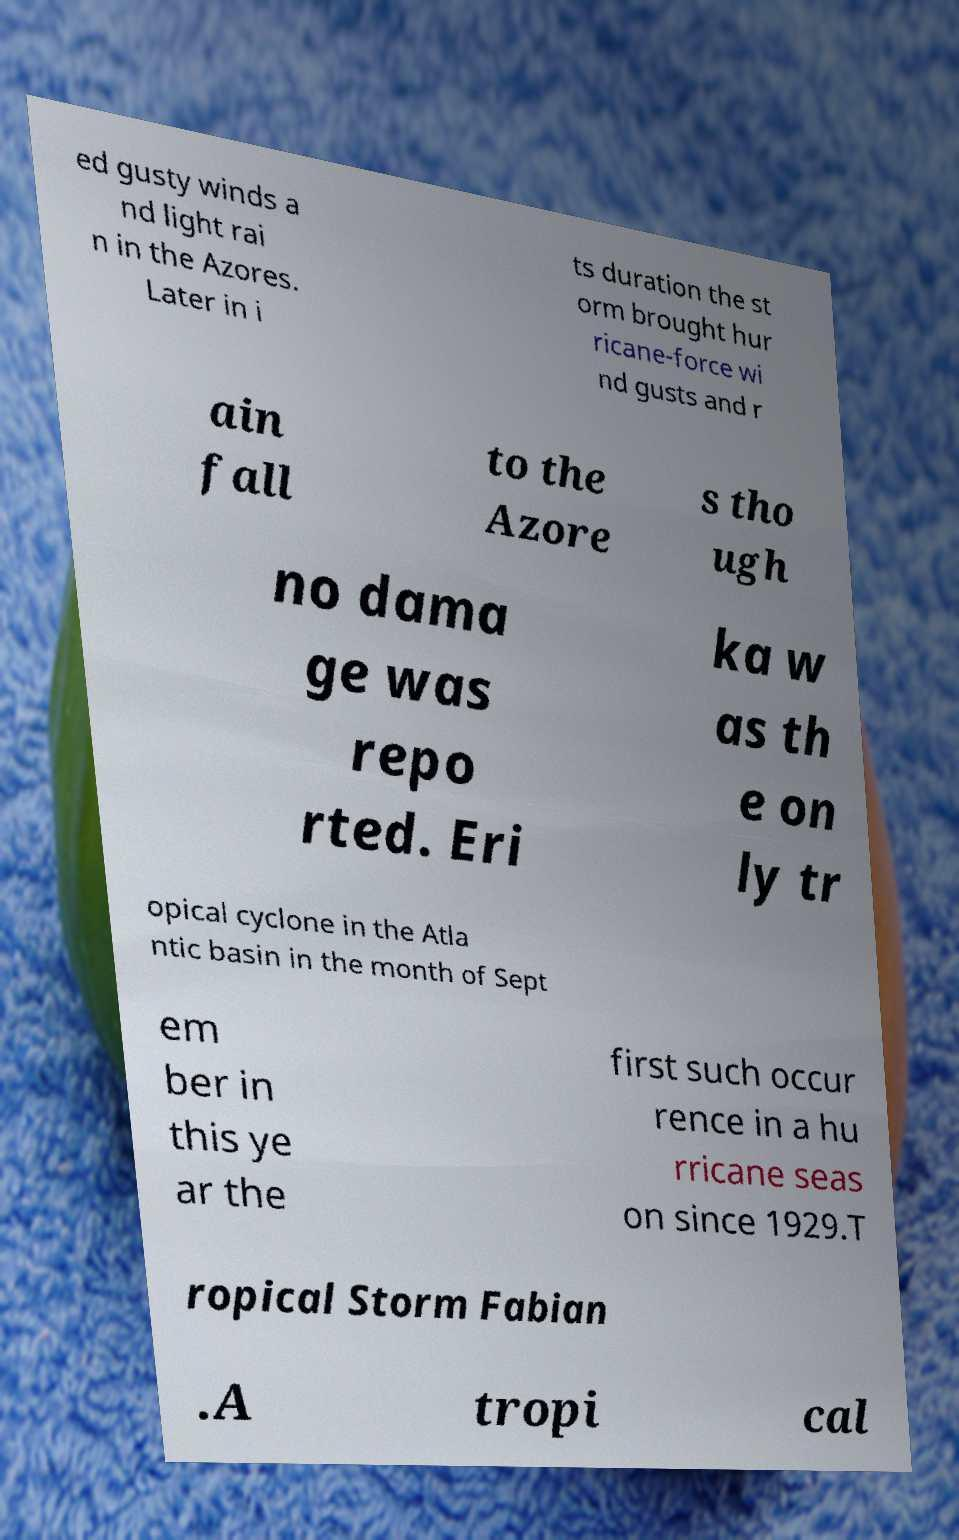What messages or text are displayed in this image? I need them in a readable, typed format. ed gusty winds a nd light rai n in the Azores. Later in i ts duration the st orm brought hur ricane-force wi nd gusts and r ain fall to the Azore s tho ugh no dama ge was repo rted. Eri ka w as th e on ly tr opical cyclone in the Atla ntic basin in the month of Sept em ber in this ye ar the first such occur rence in a hu rricane seas on since 1929.T ropical Storm Fabian .A tropi cal 